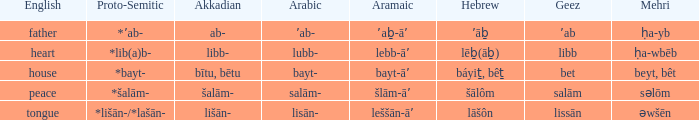If in english it is heart, what is it in hebrew? Lēḇ(āḇ). 